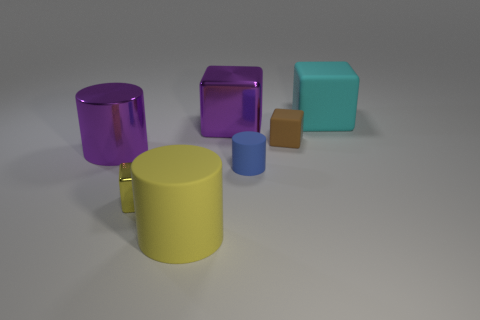Subtract all cyan blocks. How many blocks are left? 3 Add 3 big yellow things. How many objects exist? 10 Subtract all purple cubes. How many cubes are left? 3 Subtract 1 blocks. How many blocks are left? 3 Subtract 0 cyan balls. How many objects are left? 7 Subtract all cylinders. How many objects are left? 4 Subtract all blue blocks. Subtract all yellow balls. How many blocks are left? 4 Subtract all red balls. How many brown cylinders are left? 0 Subtract all small cyan matte spheres. Subtract all rubber cylinders. How many objects are left? 5 Add 2 big yellow rubber things. How many big yellow rubber things are left? 3 